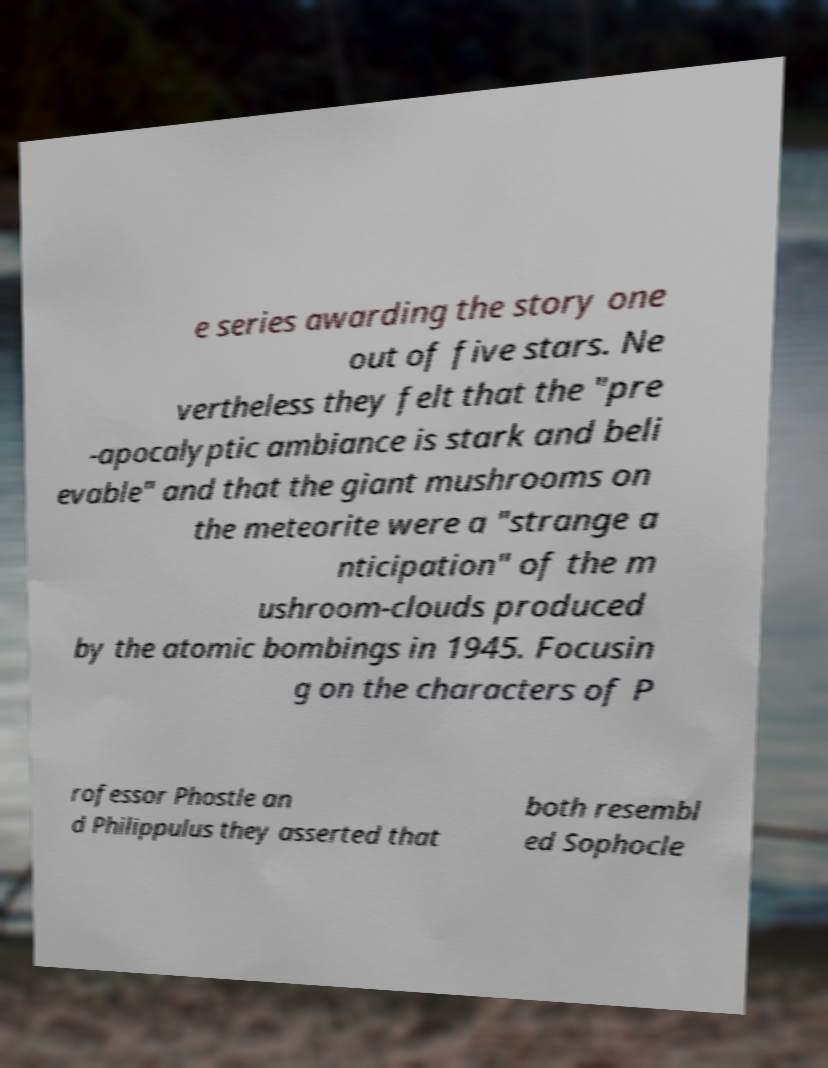I need the written content from this picture converted into text. Can you do that? e series awarding the story one out of five stars. Ne vertheless they felt that the "pre -apocalyptic ambiance is stark and beli evable" and that the giant mushrooms on the meteorite were a "strange a nticipation" of the m ushroom-clouds produced by the atomic bombings in 1945. Focusin g on the characters of P rofessor Phostle an d Philippulus they asserted that both resembl ed Sophocle 